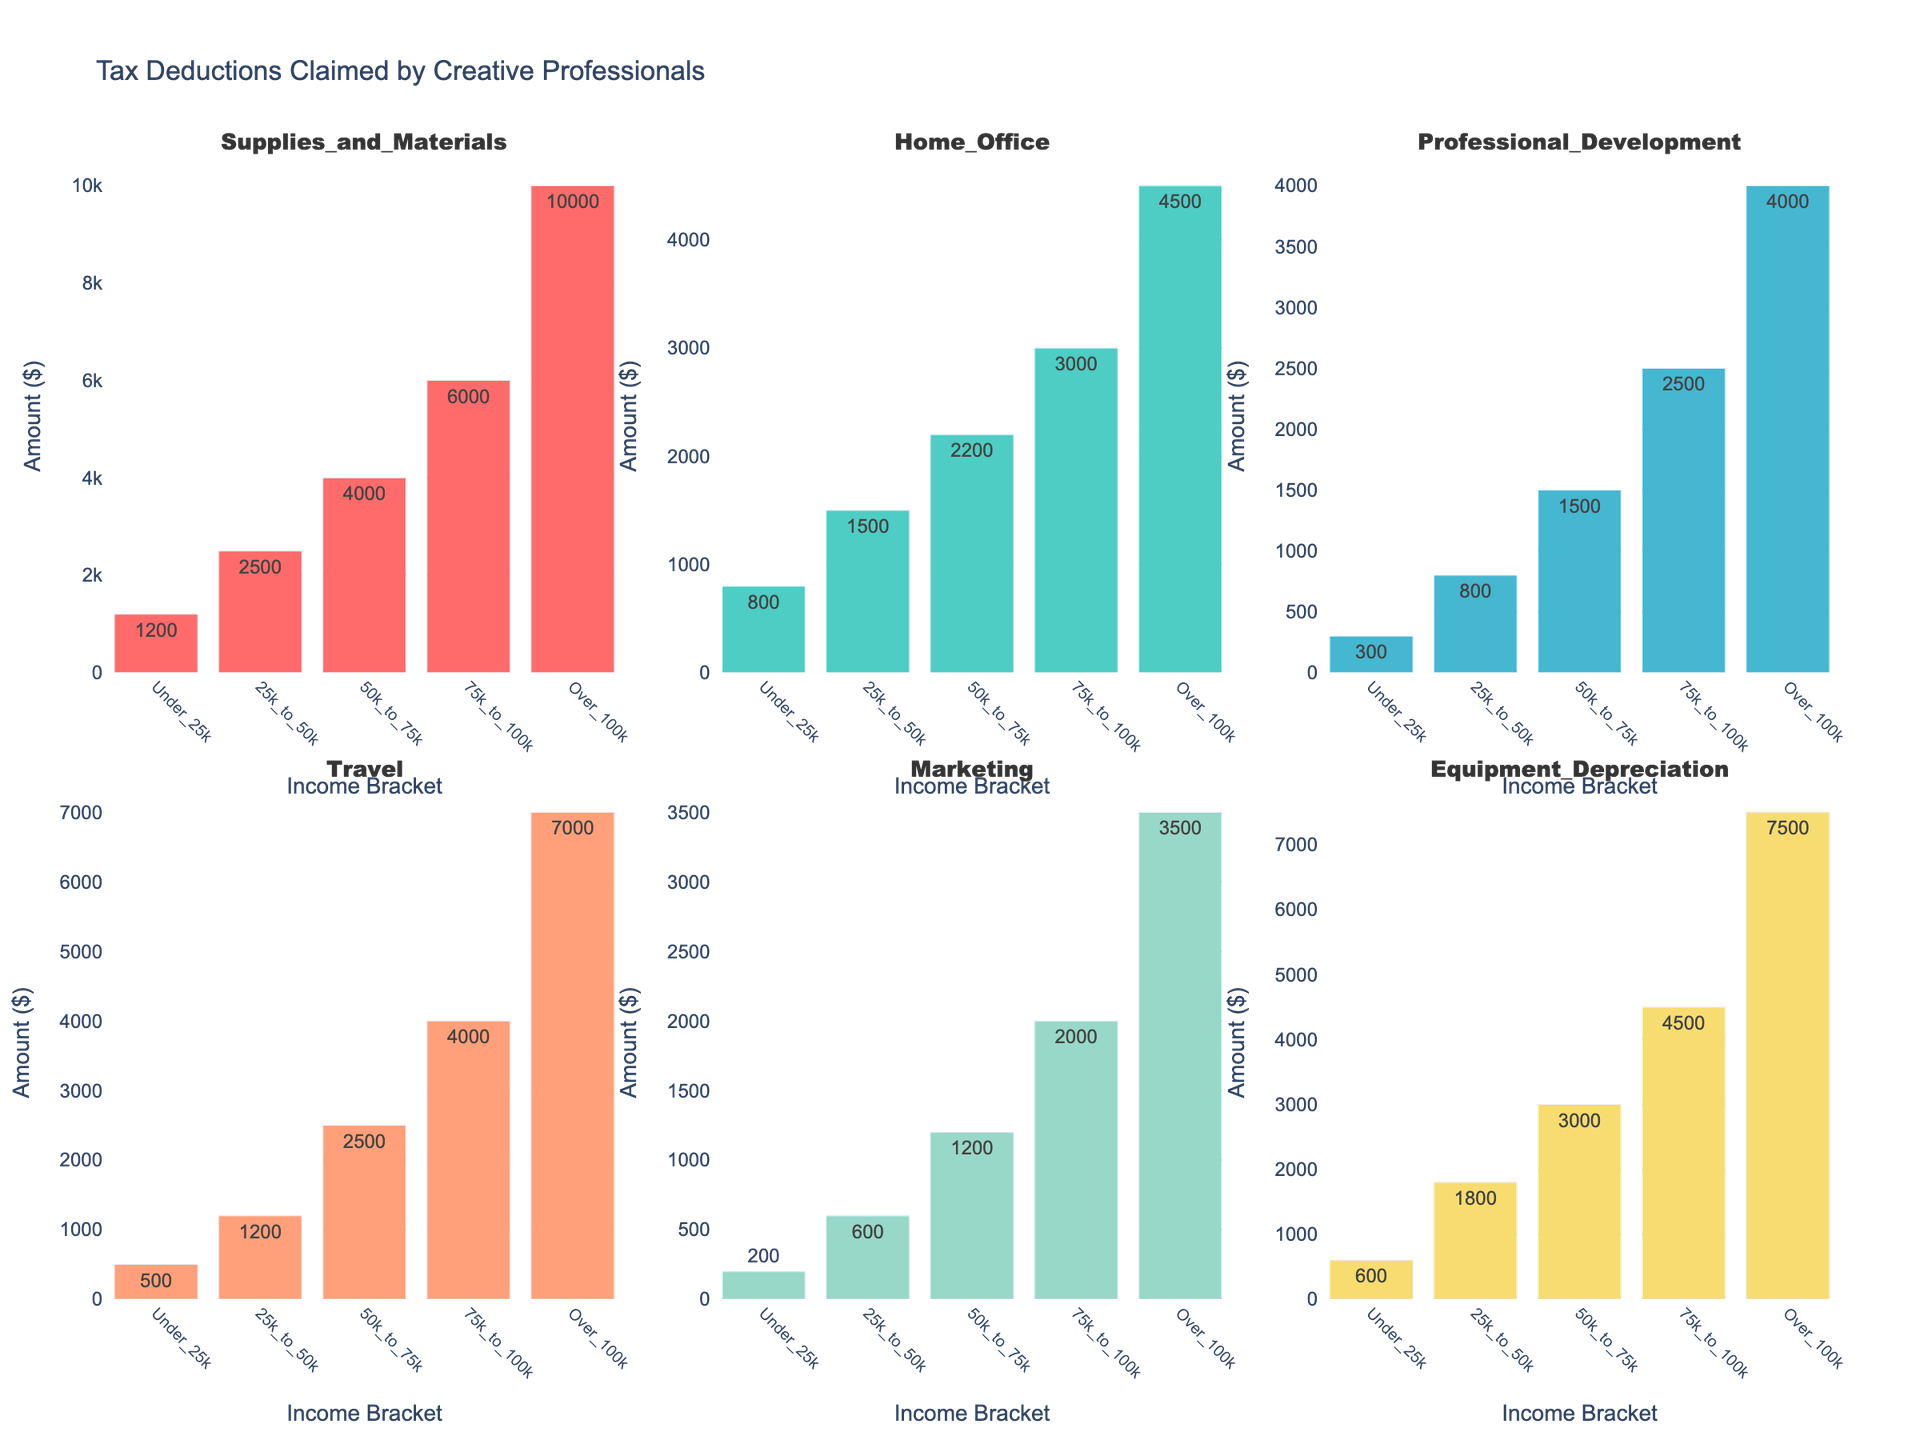What is the title of the figure? The title is located at the top center of the figure. It reads "Tax Deductions Claimed by Creative Professionals."
Answer: Tax Deductions Claimed by Creative Professionals Which income bracket claims the highest amount in Equipment Depreciation? Looking at the subplot corresponding to Equipment Depreciation, the bar reaching the highest value belongs to the Over_100k income bracket.
Answer: Over_100k How much more do individuals in the Over_100k bracket spend on Travel compared to those in the Under_25k bracket? The bar for Travel in the Over_100k bracket reaches 7000, whereas for the Under_25k bracket, it reaches 500. The difference is 7000 - 500 = 6500.
Answer: 6500 What is the average amount claimed for Marketing across all income brackets? Add the amounts for Marketing across all brackets (200 + 600 + 1200 + 2000 + 3500) and then divide by the number of brackets (5). The average is (200 + 600 + 1200 + 2000 + 3500) / 5 = 1500.
Answer: 1500 Which deduction category shows the largest increase from the Under_25k to the Over_100k bracket? To find the largest increase, compare the difference between the values in the Under_25k and Over_100k brackets for each category. The largest difference is in Supplies_and_Materials: 10000 - 1200 = 8800.
Answer: Supplies_and_Materials In which category do individuals in the 50k_to_75k bracket spend most? Look at the 50k_to_75k column for the highest value. The highest value is under Supplies_and_Materials (4000).
Answer: Supplies_and_Materials Which two categories have the closest amounts claimed by the Under_25k bracket? Compare the values for all categories in the Under_25k bracket. Home_Office is 800 and Equipment_Depreciation is 600, with a difference of 200, making them the closest.
Answer: Home_Office and Equipment_Depreciation How does the amount claimed for Professional_Development in the 25k_to_50k bracket compare to that in the 50k_to_75k bracket? The amount for Professional_Development in the 25k_to_50k bracket is 800, and in the 50k_to_75k bracket, it is 1500. The value in the 50k_to_75k bracket is higher.
Answer: 50k_to_75k is higher What are the total claims for Home_Office deductions by the Under_25k and 25k_to_50k brackets combined? Add the Home_Office deductions for the Under_25k (800) and 25k_to_50k (1500) brackets. The total is 800 + 1500 = 2300.
Answer: 2300 